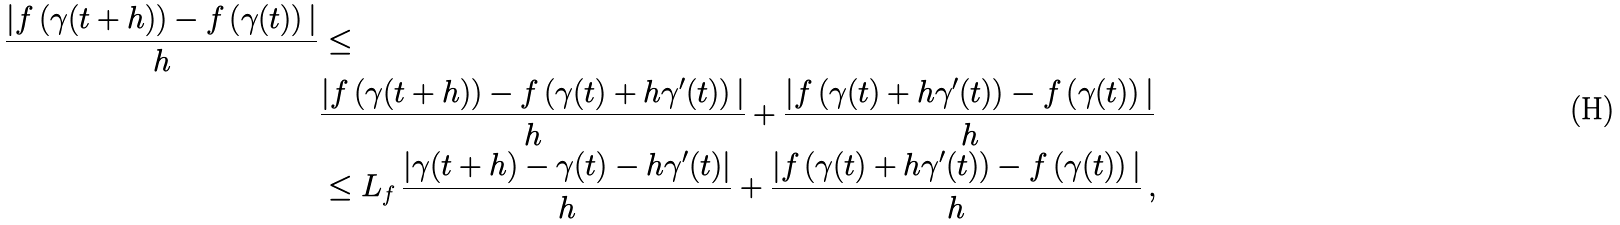<formula> <loc_0><loc_0><loc_500><loc_500>\frac { | f \left ( \gamma ( t + h ) \right ) - f \left ( \gamma ( t ) \right ) | } { h } & \leq \\ & \frac { | f \left ( \gamma ( t + h ) \right ) - f \left ( \gamma ( t ) + h \gamma ^ { \prime } ( t ) \right ) | } { h } + \frac { | f \left ( \gamma ( t ) + h \gamma ^ { \prime } ( t ) \right ) - f \left ( \gamma ( t ) \right ) | } { h } \\ & \leq L _ { f } \, \frac { | \gamma ( t + h ) - \gamma ( t ) - h \gamma ^ { \prime } ( t ) | } { h } + \frac { | f \left ( \gamma ( t ) + h \gamma ^ { \prime } ( t ) \right ) - f \left ( \gamma ( t ) \right ) | } { h } \, ,</formula> 